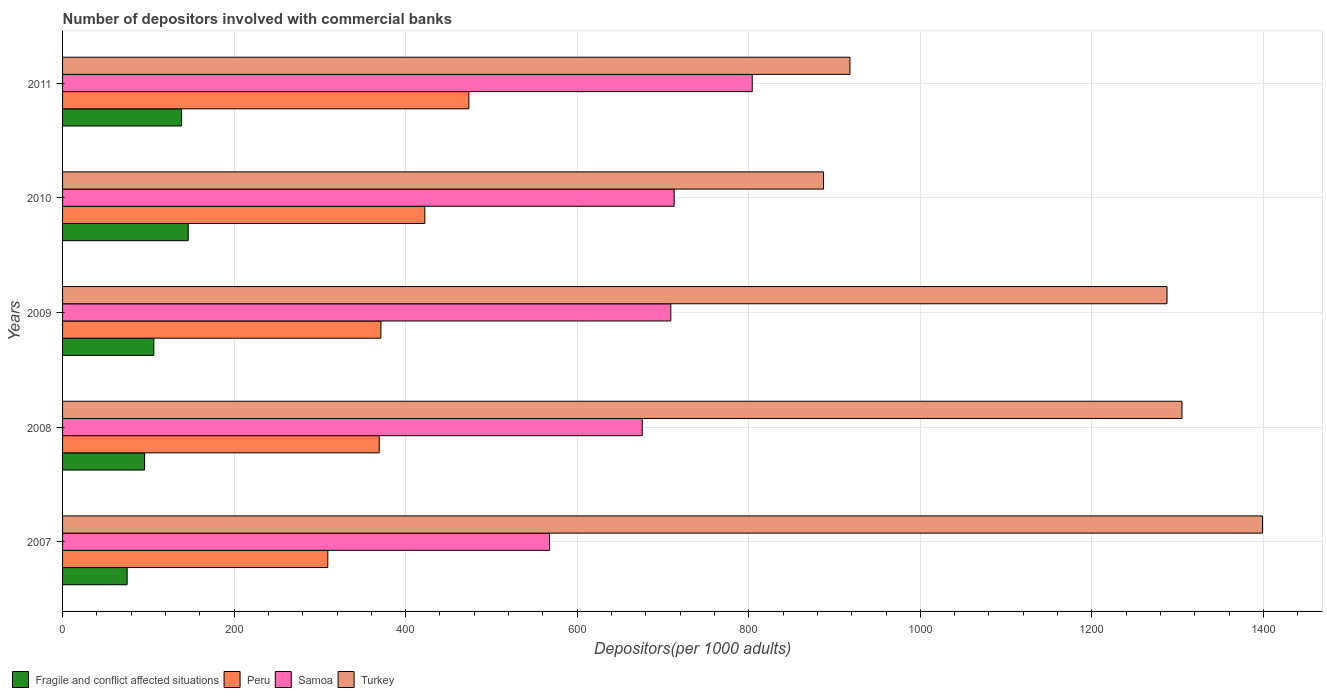How many different coloured bars are there?
Provide a succinct answer. 4. Are the number of bars per tick equal to the number of legend labels?
Provide a succinct answer. Yes. Are the number of bars on each tick of the Y-axis equal?
Give a very brief answer. Yes. How many bars are there on the 3rd tick from the bottom?
Ensure brevity in your answer.  4. What is the label of the 1st group of bars from the top?
Ensure brevity in your answer.  2011. What is the number of depositors involved with commercial banks in Turkey in 2008?
Your response must be concise. 1305.04. Across all years, what is the maximum number of depositors involved with commercial banks in Fragile and conflict affected situations?
Offer a very short reply. 146.5. Across all years, what is the minimum number of depositors involved with commercial banks in Samoa?
Your response must be concise. 567.74. What is the total number of depositors involved with commercial banks in Samoa in the graph?
Your answer should be very brief. 3469.72. What is the difference between the number of depositors involved with commercial banks in Turkey in 2009 and that in 2010?
Your response must be concise. 400.55. What is the difference between the number of depositors involved with commercial banks in Samoa in 2011 and the number of depositors involved with commercial banks in Peru in 2008?
Ensure brevity in your answer.  434.88. What is the average number of depositors involved with commercial banks in Fragile and conflict affected situations per year?
Keep it short and to the point. 112.52. In the year 2011, what is the difference between the number of depositors involved with commercial banks in Turkey and number of depositors involved with commercial banks in Peru?
Offer a terse response. 444.28. What is the ratio of the number of depositors involved with commercial banks in Samoa in 2009 to that in 2011?
Your answer should be compact. 0.88. What is the difference between the highest and the second highest number of depositors involved with commercial banks in Samoa?
Make the answer very short. 91.03. What is the difference between the highest and the lowest number of depositors involved with commercial banks in Turkey?
Keep it short and to the point. 511.84. Is it the case that in every year, the sum of the number of depositors involved with commercial banks in Samoa and number of depositors involved with commercial banks in Fragile and conflict affected situations is greater than the sum of number of depositors involved with commercial banks in Peru and number of depositors involved with commercial banks in Turkey?
Give a very brief answer. No. What does the 3rd bar from the top in 2010 represents?
Ensure brevity in your answer.  Peru. What does the 4th bar from the bottom in 2011 represents?
Offer a terse response. Turkey. Are all the bars in the graph horizontal?
Your response must be concise. Yes. Does the graph contain grids?
Offer a terse response. Yes. Where does the legend appear in the graph?
Provide a short and direct response. Bottom left. How many legend labels are there?
Keep it short and to the point. 4. What is the title of the graph?
Your answer should be compact. Number of depositors involved with commercial banks. Does "Brunei Darussalam" appear as one of the legend labels in the graph?
Give a very brief answer. No. What is the label or title of the X-axis?
Your answer should be compact. Depositors(per 1000 adults). What is the label or title of the Y-axis?
Make the answer very short. Years. What is the Depositors(per 1000 adults) in Fragile and conflict affected situations in 2007?
Provide a short and direct response. 75.3. What is the Depositors(per 1000 adults) in Peru in 2007?
Give a very brief answer. 309.23. What is the Depositors(per 1000 adults) in Samoa in 2007?
Your answer should be very brief. 567.74. What is the Depositors(per 1000 adults) in Turkey in 2007?
Give a very brief answer. 1398.93. What is the Depositors(per 1000 adults) of Fragile and conflict affected situations in 2008?
Your answer should be very brief. 95.65. What is the Depositors(per 1000 adults) in Peru in 2008?
Offer a very short reply. 369.17. What is the Depositors(per 1000 adults) of Samoa in 2008?
Provide a succinct answer. 675.82. What is the Depositors(per 1000 adults) in Turkey in 2008?
Your answer should be very brief. 1305.04. What is the Depositors(per 1000 adults) in Fragile and conflict affected situations in 2009?
Provide a short and direct response. 106.41. What is the Depositors(per 1000 adults) in Peru in 2009?
Make the answer very short. 371.13. What is the Depositors(per 1000 adults) of Samoa in 2009?
Keep it short and to the point. 709.09. What is the Depositors(per 1000 adults) of Turkey in 2009?
Keep it short and to the point. 1287.64. What is the Depositors(per 1000 adults) of Fragile and conflict affected situations in 2010?
Keep it short and to the point. 146.5. What is the Depositors(per 1000 adults) in Peru in 2010?
Make the answer very short. 422.34. What is the Depositors(per 1000 adults) in Samoa in 2010?
Provide a short and direct response. 713.02. What is the Depositors(per 1000 adults) in Turkey in 2010?
Your answer should be very brief. 887.08. What is the Depositors(per 1000 adults) of Fragile and conflict affected situations in 2011?
Offer a terse response. 138.74. What is the Depositors(per 1000 adults) of Peru in 2011?
Your answer should be very brief. 473.69. What is the Depositors(per 1000 adults) of Samoa in 2011?
Provide a short and direct response. 804.04. What is the Depositors(per 1000 adults) of Turkey in 2011?
Offer a very short reply. 917.97. Across all years, what is the maximum Depositors(per 1000 adults) of Fragile and conflict affected situations?
Provide a succinct answer. 146.5. Across all years, what is the maximum Depositors(per 1000 adults) in Peru?
Give a very brief answer. 473.69. Across all years, what is the maximum Depositors(per 1000 adults) of Samoa?
Offer a terse response. 804.04. Across all years, what is the maximum Depositors(per 1000 adults) in Turkey?
Keep it short and to the point. 1398.93. Across all years, what is the minimum Depositors(per 1000 adults) of Fragile and conflict affected situations?
Give a very brief answer. 75.3. Across all years, what is the minimum Depositors(per 1000 adults) of Peru?
Your answer should be very brief. 309.23. Across all years, what is the minimum Depositors(per 1000 adults) of Samoa?
Offer a very short reply. 567.74. Across all years, what is the minimum Depositors(per 1000 adults) in Turkey?
Your answer should be very brief. 887.08. What is the total Depositors(per 1000 adults) in Fragile and conflict affected situations in the graph?
Offer a terse response. 562.6. What is the total Depositors(per 1000 adults) of Peru in the graph?
Your answer should be very brief. 1945.56. What is the total Depositors(per 1000 adults) in Samoa in the graph?
Your answer should be compact. 3469.72. What is the total Depositors(per 1000 adults) in Turkey in the graph?
Give a very brief answer. 5796.66. What is the difference between the Depositors(per 1000 adults) of Fragile and conflict affected situations in 2007 and that in 2008?
Keep it short and to the point. -20.35. What is the difference between the Depositors(per 1000 adults) in Peru in 2007 and that in 2008?
Offer a very short reply. -59.93. What is the difference between the Depositors(per 1000 adults) of Samoa in 2007 and that in 2008?
Give a very brief answer. -108.08. What is the difference between the Depositors(per 1000 adults) of Turkey in 2007 and that in 2008?
Keep it short and to the point. 93.88. What is the difference between the Depositors(per 1000 adults) in Fragile and conflict affected situations in 2007 and that in 2009?
Your answer should be compact. -31.11. What is the difference between the Depositors(per 1000 adults) in Peru in 2007 and that in 2009?
Your answer should be compact. -61.9. What is the difference between the Depositors(per 1000 adults) in Samoa in 2007 and that in 2009?
Make the answer very short. -141.35. What is the difference between the Depositors(per 1000 adults) of Turkey in 2007 and that in 2009?
Give a very brief answer. 111.29. What is the difference between the Depositors(per 1000 adults) in Fragile and conflict affected situations in 2007 and that in 2010?
Make the answer very short. -71.2. What is the difference between the Depositors(per 1000 adults) of Peru in 2007 and that in 2010?
Give a very brief answer. -113.11. What is the difference between the Depositors(per 1000 adults) in Samoa in 2007 and that in 2010?
Your response must be concise. -145.27. What is the difference between the Depositors(per 1000 adults) in Turkey in 2007 and that in 2010?
Ensure brevity in your answer.  511.84. What is the difference between the Depositors(per 1000 adults) of Fragile and conflict affected situations in 2007 and that in 2011?
Provide a succinct answer. -63.44. What is the difference between the Depositors(per 1000 adults) in Peru in 2007 and that in 2011?
Make the answer very short. -164.46. What is the difference between the Depositors(per 1000 adults) of Samoa in 2007 and that in 2011?
Your answer should be very brief. -236.3. What is the difference between the Depositors(per 1000 adults) of Turkey in 2007 and that in 2011?
Provide a succinct answer. 480.96. What is the difference between the Depositors(per 1000 adults) of Fragile and conflict affected situations in 2008 and that in 2009?
Make the answer very short. -10.75. What is the difference between the Depositors(per 1000 adults) of Peru in 2008 and that in 2009?
Your response must be concise. -1.97. What is the difference between the Depositors(per 1000 adults) in Samoa in 2008 and that in 2009?
Offer a very short reply. -33.27. What is the difference between the Depositors(per 1000 adults) of Turkey in 2008 and that in 2009?
Your answer should be compact. 17.41. What is the difference between the Depositors(per 1000 adults) in Fragile and conflict affected situations in 2008 and that in 2010?
Give a very brief answer. -50.84. What is the difference between the Depositors(per 1000 adults) in Peru in 2008 and that in 2010?
Your answer should be compact. -53.18. What is the difference between the Depositors(per 1000 adults) of Samoa in 2008 and that in 2010?
Keep it short and to the point. -37.2. What is the difference between the Depositors(per 1000 adults) in Turkey in 2008 and that in 2010?
Offer a terse response. 417.96. What is the difference between the Depositors(per 1000 adults) of Fragile and conflict affected situations in 2008 and that in 2011?
Your response must be concise. -43.09. What is the difference between the Depositors(per 1000 adults) of Peru in 2008 and that in 2011?
Provide a succinct answer. -104.52. What is the difference between the Depositors(per 1000 adults) in Samoa in 2008 and that in 2011?
Your response must be concise. -128.22. What is the difference between the Depositors(per 1000 adults) in Turkey in 2008 and that in 2011?
Provide a succinct answer. 387.08. What is the difference between the Depositors(per 1000 adults) of Fragile and conflict affected situations in 2009 and that in 2010?
Ensure brevity in your answer.  -40.09. What is the difference between the Depositors(per 1000 adults) of Peru in 2009 and that in 2010?
Keep it short and to the point. -51.21. What is the difference between the Depositors(per 1000 adults) in Samoa in 2009 and that in 2010?
Provide a short and direct response. -3.93. What is the difference between the Depositors(per 1000 adults) in Turkey in 2009 and that in 2010?
Provide a succinct answer. 400.55. What is the difference between the Depositors(per 1000 adults) in Fragile and conflict affected situations in 2009 and that in 2011?
Provide a short and direct response. -32.34. What is the difference between the Depositors(per 1000 adults) of Peru in 2009 and that in 2011?
Make the answer very short. -102.56. What is the difference between the Depositors(per 1000 adults) in Samoa in 2009 and that in 2011?
Ensure brevity in your answer.  -94.95. What is the difference between the Depositors(per 1000 adults) of Turkey in 2009 and that in 2011?
Offer a very short reply. 369.67. What is the difference between the Depositors(per 1000 adults) of Fragile and conflict affected situations in 2010 and that in 2011?
Your response must be concise. 7.75. What is the difference between the Depositors(per 1000 adults) in Peru in 2010 and that in 2011?
Make the answer very short. -51.35. What is the difference between the Depositors(per 1000 adults) of Samoa in 2010 and that in 2011?
Your response must be concise. -91.03. What is the difference between the Depositors(per 1000 adults) of Turkey in 2010 and that in 2011?
Provide a short and direct response. -30.88. What is the difference between the Depositors(per 1000 adults) of Fragile and conflict affected situations in 2007 and the Depositors(per 1000 adults) of Peru in 2008?
Provide a short and direct response. -293.87. What is the difference between the Depositors(per 1000 adults) of Fragile and conflict affected situations in 2007 and the Depositors(per 1000 adults) of Samoa in 2008?
Your answer should be very brief. -600.52. What is the difference between the Depositors(per 1000 adults) in Fragile and conflict affected situations in 2007 and the Depositors(per 1000 adults) in Turkey in 2008?
Provide a short and direct response. -1229.75. What is the difference between the Depositors(per 1000 adults) of Peru in 2007 and the Depositors(per 1000 adults) of Samoa in 2008?
Ensure brevity in your answer.  -366.59. What is the difference between the Depositors(per 1000 adults) of Peru in 2007 and the Depositors(per 1000 adults) of Turkey in 2008?
Offer a terse response. -995.81. What is the difference between the Depositors(per 1000 adults) in Samoa in 2007 and the Depositors(per 1000 adults) in Turkey in 2008?
Provide a succinct answer. -737.3. What is the difference between the Depositors(per 1000 adults) of Fragile and conflict affected situations in 2007 and the Depositors(per 1000 adults) of Peru in 2009?
Your answer should be very brief. -295.83. What is the difference between the Depositors(per 1000 adults) in Fragile and conflict affected situations in 2007 and the Depositors(per 1000 adults) in Samoa in 2009?
Ensure brevity in your answer.  -633.79. What is the difference between the Depositors(per 1000 adults) in Fragile and conflict affected situations in 2007 and the Depositors(per 1000 adults) in Turkey in 2009?
Provide a short and direct response. -1212.34. What is the difference between the Depositors(per 1000 adults) of Peru in 2007 and the Depositors(per 1000 adults) of Samoa in 2009?
Provide a short and direct response. -399.86. What is the difference between the Depositors(per 1000 adults) in Peru in 2007 and the Depositors(per 1000 adults) in Turkey in 2009?
Make the answer very short. -978.4. What is the difference between the Depositors(per 1000 adults) in Samoa in 2007 and the Depositors(per 1000 adults) in Turkey in 2009?
Provide a short and direct response. -719.89. What is the difference between the Depositors(per 1000 adults) in Fragile and conflict affected situations in 2007 and the Depositors(per 1000 adults) in Peru in 2010?
Provide a short and direct response. -347.04. What is the difference between the Depositors(per 1000 adults) in Fragile and conflict affected situations in 2007 and the Depositors(per 1000 adults) in Samoa in 2010?
Ensure brevity in your answer.  -637.72. What is the difference between the Depositors(per 1000 adults) in Fragile and conflict affected situations in 2007 and the Depositors(per 1000 adults) in Turkey in 2010?
Give a very brief answer. -811.78. What is the difference between the Depositors(per 1000 adults) of Peru in 2007 and the Depositors(per 1000 adults) of Samoa in 2010?
Your answer should be very brief. -403.79. What is the difference between the Depositors(per 1000 adults) in Peru in 2007 and the Depositors(per 1000 adults) in Turkey in 2010?
Keep it short and to the point. -577.85. What is the difference between the Depositors(per 1000 adults) in Samoa in 2007 and the Depositors(per 1000 adults) in Turkey in 2010?
Keep it short and to the point. -319.34. What is the difference between the Depositors(per 1000 adults) of Fragile and conflict affected situations in 2007 and the Depositors(per 1000 adults) of Peru in 2011?
Keep it short and to the point. -398.39. What is the difference between the Depositors(per 1000 adults) of Fragile and conflict affected situations in 2007 and the Depositors(per 1000 adults) of Samoa in 2011?
Make the answer very short. -728.74. What is the difference between the Depositors(per 1000 adults) in Fragile and conflict affected situations in 2007 and the Depositors(per 1000 adults) in Turkey in 2011?
Make the answer very short. -842.67. What is the difference between the Depositors(per 1000 adults) of Peru in 2007 and the Depositors(per 1000 adults) of Samoa in 2011?
Your answer should be very brief. -494.81. What is the difference between the Depositors(per 1000 adults) in Peru in 2007 and the Depositors(per 1000 adults) in Turkey in 2011?
Make the answer very short. -608.73. What is the difference between the Depositors(per 1000 adults) in Samoa in 2007 and the Depositors(per 1000 adults) in Turkey in 2011?
Offer a terse response. -350.22. What is the difference between the Depositors(per 1000 adults) in Fragile and conflict affected situations in 2008 and the Depositors(per 1000 adults) in Peru in 2009?
Offer a very short reply. -275.48. What is the difference between the Depositors(per 1000 adults) of Fragile and conflict affected situations in 2008 and the Depositors(per 1000 adults) of Samoa in 2009?
Provide a succinct answer. -613.44. What is the difference between the Depositors(per 1000 adults) in Fragile and conflict affected situations in 2008 and the Depositors(per 1000 adults) in Turkey in 2009?
Keep it short and to the point. -1191.98. What is the difference between the Depositors(per 1000 adults) in Peru in 2008 and the Depositors(per 1000 adults) in Samoa in 2009?
Offer a very short reply. -339.92. What is the difference between the Depositors(per 1000 adults) of Peru in 2008 and the Depositors(per 1000 adults) of Turkey in 2009?
Offer a very short reply. -918.47. What is the difference between the Depositors(per 1000 adults) of Samoa in 2008 and the Depositors(per 1000 adults) of Turkey in 2009?
Give a very brief answer. -611.81. What is the difference between the Depositors(per 1000 adults) of Fragile and conflict affected situations in 2008 and the Depositors(per 1000 adults) of Peru in 2010?
Make the answer very short. -326.69. What is the difference between the Depositors(per 1000 adults) of Fragile and conflict affected situations in 2008 and the Depositors(per 1000 adults) of Samoa in 2010?
Your answer should be very brief. -617.37. What is the difference between the Depositors(per 1000 adults) in Fragile and conflict affected situations in 2008 and the Depositors(per 1000 adults) in Turkey in 2010?
Your response must be concise. -791.43. What is the difference between the Depositors(per 1000 adults) of Peru in 2008 and the Depositors(per 1000 adults) of Samoa in 2010?
Provide a succinct answer. -343.85. What is the difference between the Depositors(per 1000 adults) of Peru in 2008 and the Depositors(per 1000 adults) of Turkey in 2010?
Provide a succinct answer. -517.92. What is the difference between the Depositors(per 1000 adults) in Samoa in 2008 and the Depositors(per 1000 adults) in Turkey in 2010?
Give a very brief answer. -211.26. What is the difference between the Depositors(per 1000 adults) of Fragile and conflict affected situations in 2008 and the Depositors(per 1000 adults) of Peru in 2011?
Your answer should be compact. -378.04. What is the difference between the Depositors(per 1000 adults) in Fragile and conflict affected situations in 2008 and the Depositors(per 1000 adults) in Samoa in 2011?
Make the answer very short. -708.39. What is the difference between the Depositors(per 1000 adults) in Fragile and conflict affected situations in 2008 and the Depositors(per 1000 adults) in Turkey in 2011?
Make the answer very short. -822.32. What is the difference between the Depositors(per 1000 adults) of Peru in 2008 and the Depositors(per 1000 adults) of Samoa in 2011?
Your response must be concise. -434.88. What is the difference between the Depositors(per 1000 adults) in Peru in 2008 and the Depositors(per 1000 adults) in Turkey in 2011?
Keep it short and to the point. -548.8. What is the difference between the Depositors(per 1000 adults) in Samoa in 2008 and the Depositors(per 1000 adults) in Turkey in 2011?
Offer a terse response. -242.14. What is the difference between the Depositors(per 1000 adults) of Fragile and conflict affected situations in 2009 and the Depositors(per 1000 adults) of Peru in 2010?
Your response must be concise. -315.94. What is the difference between the Depositors(per 1000 adults) of Fragile and conflict affected situations in 2009 and the Depositors(per 1000 adults) of Samoa in 2010?
Provide a succinct answer. -606.61. What is the difference between the Depositors(per 1000 adults) in Fragile and conflict affected situations in 2009 and the Depositors(per 1000 adults) in Turkey in 2010?
Your response must be concise. -780.68. What is the difference between the Depositors(per 1000 adults) in Peru in 2009 and the Depositors(per 1000 adults) in Samoa in 2010?
Ensure brevity in your answer.  -341.89. What is the difference between the Depositors(per 1000 adults) of Peru in 2009 and the Depositors(per 1000 adults) of Turkey in 2010?
Make the answer very short. -515.95. What is the difference between the Depositors(per 1000 adults) of Samoa in 2009 and the Depositors(per 1000 adults) of Turkey in 2010?
Ensure brevity in your answer.  -177.99. What is the difference between the Depositors(per 1000 adults) in Fragile and conflict affected situations in 2009 and the Depositors(per 1000 adults) in Peru in 2011?
Provide a short and direct response. -367.28. What is the difference between the Depositors(per 1000 adults) in Fragile and conflict affected situations in 2009 and the Depositors(per 1000 adults) in Samoa in 2011?
Ensure brevity in your answer.  -697.64. What is the difference between the Depositors(per 1000 adults) of Fragile and conflict affected situations in 2009 and the Depositors(per 1000 adults) of Turkey in 2011?
Offer a terse response. -811.56. What is the difference between the Depositors(per 1000 adults) of Peru in 2009 and the Depositors(per 1000 adults) of Samoa in 2011?
Make the answer very short. -432.91. What is the difference between the Depositors(per 1000 adults) in Peru in 2009 and the Depositors(per 1000 adults) in Turkey in 2011?
Make the answer very short. -546.83. What is the difference between the Depositors(per 1000 adults) of Samoa in 2009 and the Depositors(per 1000 adults) of Turkey in 2011?
Provide a short and direct response. -208.88. What is the difference between the Depositors(per 1000 adults) in Fragile and conflict affected situations in 2010 and the Depositors(per 1000 adults) in Peru in 2011?
Give a very brief answer. -327.19. What is the difference between the Depositors(per 1000 adults) of Fragile and conflict affected situations in 2010 and the Depositors(per 1000 adults) of Samoa in 2011?
Provide a succinct answer. -657.55. What is the difference between the Depositors(per 1000 adults) in Fragile and conflict affected situations in 2010 and the Depositors(per 1000 adults) in Turkey in 2011?
Your answer should be very brief. -771.47. What is the difference between the Depositors(per 1000 adults) in Peru in 2010 and the Depositors(per 1000 adults) in Samoa in 2011?
Your response must be concise. -381.7. What is the difference between the Depositors(per 1000 adults) of Peru in 2010 and the Depositors(per 1000 adults) of Turkey in 2011?
Provide a succinct answer. -495.63. What is the difference between the Depositors(per 1000 adults) of Samoa in 2010 and the Depositors(per 1000 adults) of Turkey in 2011?
Make the answer very short. -204.95. What is the average Depositors(per 1000 adults) in Fragile and conflict affected situations per year?
Your answer should be compact. 112.52. What is the average Depositors(per 1000 adults) of Peru per year?
Your response must be concise. 389.11. What is the average Depositors(per 1000 adults) of Samoa per year?
Your response must be concise. 693.94. What is the average Depositors(per 1000 adults) in Turkey per year?
Offer a very short reply. 1159.33. In the year 2007, what is the difference between the Depositors(per 1000 adults) in Fragile and conflict affected situations and Depositors(per 1000 adults) in Peru?
Your answer should be very brief. -233.93. In the year 2007, what is the difference between the Depositors(per 1000 adults) of Fragile and conflict affected situations and Depositors(per 1000 adults) of Samoa?
Make the answer very short. -492.45. In the year 2007, what is the difference between the Depositors(per 1000 adults) in Fragile and conflict affected situations and Depositors(per 1000 adults) in Turkey?
Ensure brevity in your answer.  -1323.63. In the year 2007, what is the difference between the Depositors(per 1000 adults) of Peru and Depositors(per 1000 adults) of Samoa?
Offer a terse response. -258.51. In the year 2007, what is the difference between the Depositors(per 1000 adults) in Peru and Depositors(per 1000 adults) in Turkey?
Your response must be concise. -1089.69. In the year 2007, what is the difference between the Depositors(per 1000 adults) of Samoa and Depositors(per 1000 adults) of Turkey?
Provide a short and direct response. -831.18. In the year 2008, what is the difference between the Depositors(per 1000 adults) of Fragile and conflict affected situations and Depositors(per 1000 adults) of Peru?
Ensure brevity in your answer.  -273.51. In the year 2008, what is the difference between the Depositors(per 1000 adults) in Fragile and conflict affected situations and Depositors(per 1000 adults) in Samoa?
Keep it short and to the point. -580.17. In the year 2008, what is the difference between the Depositors(per 1000 adults) of Fragile and conflict affected situations and Depositors(per 1000 adults) of Turkey?
Your response must be concise. -1209.39. In the year 2008, what is the difference between the Depositors(per 1000 adults) of Peru and Depositors(per 1000 adults) of Samoa?
Your response must be concise. -306.66. In the year 2008, what is the difference between the Depositors(per 1000 adults) in Peru and Depositors(per 1000 adults) in Turkey?
Provide a succinct answer. -935.88. In the year 2008, what is the difference between the Depositors(per 1000 adults) in Samoa and Depositors(per 1000 adults) in Turkey?
Keep it short and to the point. -629.22. In the year 2009, what is the difference between the Depositors(per 1000 adults) in Fragile and conflict affected situations and Depositors(per 1000 adults) in Peru?
Your response must be concise. -264.73. In the year 2009, what is the difference between the Depositors(per 1000 adults) of Fragile and conflict affected situations and Depositors(per 1000 adults) of Samoa?
Give a very brief answer. -602.68. In the year 2009, what is the difference between the Depositors(per 1000 adults) of Fragile and conflict affected situations and Depositors(per 1000 adults) of Turkey?
Offer a terse response. -1181.23. In the year 2009, what is the difference between the Depositors(per 1000 adults) in Peru and Depositors(per 1000 adults) in Samoa?
Make the answer very short. -337.96. In the year 2009, what is the difference between the Depositors(per 1000 adults) of Peru and Depositors(per 1000 adults) of Turkey?
Your answer should be very brief. -916.5. In the year 2009, what is the difference between the Depositors(per 1000 adults) in Samoa and Depositors(per 1000 adults) in Turkey?
Your answer should be compact. -578.55. In the year 2010, what is the difference between the Depositors(per 1000 adults) of Fragile and conflict affected situations and Depositors(per 1000 adults) of Peru?
Your answer should be compact. -275.85. In the year 2010, what is the difference between the Depositors(per 1000 adults) of Fragile and conflict affected situations and Depositors(per 1000 adults) of Samoa?
Keep it short and to the point. -566.52. In the year 2010, what is the difference between the Depositors(per 1000 adults) in Fragile and conflict affected situations and Depositors(per 1000 adults) in Turkey?
Offer a very short reply. -740.59. In the year 2010, what is the difference between the Depositors(per 1000 adults) in Peru and Depositors(per 1000 adults) in Samoa?
Offer a very short reply. -290.68. In the year 2010, what is the difference between the Depositors(per 1000 adults) of Peru and Depositors(per 1000 adults) of Turkey?
Offer a very short reply. -464.74. In the year 2010, what is the difference between the Depositors(per 1000 adults) in Samoa and Depositors(per 1000 adults) in Turkey?
Keep it short and to the point. -174.06. In the year 2011, what is the difference between the Depositors(per 1000 adults) in Fragile and conflict affected situations and Depositors(per 1000 adults) in Peru?
Keep it short and to the point. -334.95. In the year 2011, what is the difference between the Depositors(per 1000 adults) of Fragile and conflict affected situations and Depositors(per 1000 adults) of Samoa?
Offer a terse response. -665.3. In the year 2011, what is the difference between the Depositors(per 1000 adults) of Fragile and conflict affected situations and Depositors(per 1000 adults) of Turkey?
Your answer should be very brief. -779.22. In the year 2011, what is the difference between the Depositors(per 1000 adults) in Peru and Depositors(per 1000 adults) in Samoa?
Your answer should be very brief. -330.35. In the year 2011, what is the difference between the Depositors(per 1000 adults) in Peru and Depositors(per 1000 adults) in Turkey?
Provide a short and direct response. -444.28. In the year 2011, what is the difference between the Depositors(per 1000 adults) in Samoa and Depositors(per 1000 adults) in Turkey?
Your response must be concise. -113.92. What is the ratio of the Depositors(per 1000 adults) in Fragile and conflict affected situations in 2007 to that in 2008?
Make the answer very short. 0.79. What is the ratio of the Depositors(per 1000 adults) in Peru in 2007 to that in 2008?
Provide a succinct answer. 0.84. What is the ratio of the Depositors(per 1000 adults) in Samoa in 2007 to that in 2008?
Provide a succinct answer. 0.84. What is the ratio of the Depositors(per 1000 adults) in Turkey in 2007 to that in 2008?
Offer a very short reply. 1.07. What is the ratio of the Depositors(per 1000 adults) of Fragile and conflict affected situations in 2007 to that in 2009?
Offer a terse response. 0.71. What is the ratio of the Depositors(per 1000 adults) in Peru in 2007 to that in 2009?
Make the answer very short. 0.83. What is the ratio of the Depositors(per 1000 adults) of Samoa in 2007 to that in 2009?
Keep it short and to the point. 0.8. What is the ratio of the Depositors(per 1000 adults) of Turkey in 2007 to that in 2009?
Give a very brief answer. 1.09. What is the ratio of the Depositors(per 1000 adults) in Fragile and conflict affected situations in 2007 to that in 2010?
Offer a terse response. 0.51. What is the ratio of the Depositors(per 1000 adults) of Peru in 2007 to that in 2010?
Your response must be concise. 0.73. What is the ratio of the Depositors(per 1000 adults) of Samoa in 2007 to that in 2010?
Make the answer very short. 0.8. What is the ratio of the Depositors(per 1000 adults) of Turkey in 2007 to that in 2010?
Provide a succinct answer. 1.58. What is the ratio of the Depositors(per 1000 adults) in Fragile and conflict affected situations in 2007 to that in 2011?
Ensure brevity in your answer.  0.54. What is the ratio of the Depositors(per 1000 adults) of Peru in 2007 to that in 2011?
Give a very brief answer. 0.65. What is the ratio of the Depositors(per 1000 adults) of Samoa in 2007 to that in 2011?
Offer a terse response. 0.71. What is the ratio of the Depositors(per 1000 adults) in Turkey in 2007 to that in 2011?
Provide a short and direct response. 1.52. What is the ratio of the Depositors(per 1000 adults) of Fragile and conflict affected situations in 2008 to that in 2009?
Keep it short and to the point. 0.9. What is the ratio of the Depositors(per 1000 adults) in Samoa in 2008 to that in 2009?
Your answer should be compact. 0.95. What is the ratio of the Depositors(per 1000 adults) of Turkey in 2008 to that in 2009?
Your answer should be very brief. 1.01. What is the ratio of the Depositors(per 1000 adults) of Fragile and conflict affected situations in 2008 to that in 2010?
Your response must be concise. 0.65. What is the ratio of the Depositors(per 1000 adults) of Peru in 2008 to that in 2010?
Offer a very short reply. 0.87. What is the ratio of the Depositors(per 1000 adults) in Samoa in 2008 to that in 2010?
Keep it short and to the point. 0.95. What is the ratio of the Depositors(per 1000 adults) of Turkey in 2008 to that in 2010?
Your answer should be very brief. 1.47. What is the ratio of the Depositors(per 1000 adults) in Fragile and conflict affected situations in 2008 to that in 2011?
Offer a terse response. 0.69. What is the ratio of the Depositors(per 1000 adults) in Peru in 2008 to that in 2011?
Provide a succinct answer. 0.78. What is the ratio of the Depositors(per 1000 adults) in Samoa in 2008 to that in 2011?
Your answer should be compact. 0.84. What is the ratio of the Depositors(per 1000 adults) of Turkey in 2008 to that in 2011?
Offer a terse response. 1.42. What is the ratio of the Depositors(per 1000 adults) of Fragile and conflict affected situations in 2009 to that in 2010?
Ensure brevity in your answer.  0.73. What is the ratio of the Depositors(per 1000 adults) of Peru in 2009 to that in 2010?
Give a very brief answer. 0.88. What is the ratio of the Depositors(per 1000 adults) of Turkey in 2009 to that in 2010?
Offer a very short reply. 1.45. What is the ratio of the Depositors(per 1000 adults) in Fragile and conflict affected situations in 2009 to that in 2011?
Your response must be concise. 0.77. What is the ratio of the Depositors(per 1000 adults) of Peru in 2009 to that in 2011?
Give a very brief answer. 0.78. What is the ratio of the Depositors(per 1000 adults) in Samoa in 2009 to that in 2011?
Your answer should be compact. 0.88. What is the ratio of the Depositors(per 1000 adults) of Turkey in 2009 to that in 2011?
Your answer should be very brief. 1.4. What is the ratio of the Depositors(per 1000 adults) in Fragile and conflict affected situations in 2010 to that in 2011?
Offer a very short reply. 1.06. What is the ratio of the Depositors(per 1000 adults) in Peru in 2010 to that in 2011?
Provide a short and direct response. 0.89. What is the ratio of the Depositors(per 1000 adults) in Samoa in 2010 to that in 2011?
Offer a very short reply. 0.89. What is the ratio of the Depositors(per 1000 adults) of Turkey in 2010 to that in 2011?
Your answer should be compact. 0.97. What is the difference between the highest and the second highest Depositors(per 1000 adults) in Fragile and conflict affected situations?
Make the answer very short. 7.75. What is the difference between the highest and the second highest Depositors(per 1000 adults) of Peru?
Make the answer very short. 51.35. What is the difference between the highest and the second highest Depositors(per 1000 adults) in Samoa?
Your answer should be compact. 91.03. What is the difference between the highest and the second highest Depositors(per 1000 adults) in Turkey?
Offer a terse response. 93.88. What is the difference between the highest and the lowest Depositors(per 1000 adults) in Fragile and conflict affected situations?
Provide a short and direct response. 71.2. What is the difference between the highest and the lowest Depositors(per 1000 adults) in Peru?
Your answer should be compact. 164.46. What is the difference between the highest and the lowest Depositors(per 1000 adults) of Samoa?
Your answer should be very brief. 236.3. What is the difference between the highest and the lowest Depositors(per 1000 adults) of Turkey?
Your answer should be compact. 511.84. 